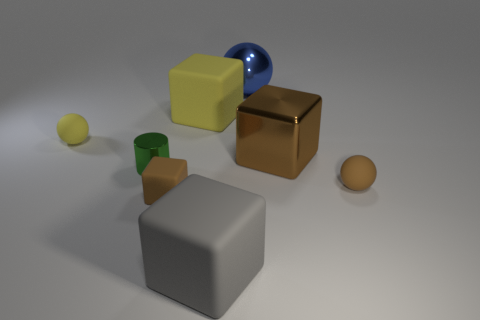Add 1 small shiny cylinders. How many objects exist? 9 Subtract all cylinders. How many objects are left? 7 Subtract all small cylinders. Subtract all blue shiny balls. How many objects are left? 6 Add 4 tiny matte balls. How many tiny matte balls are left? 6 Add 1 brown objects. How many brown objects exist? 4 Subtract 0 cyan spheres. How many objects are left? 8 